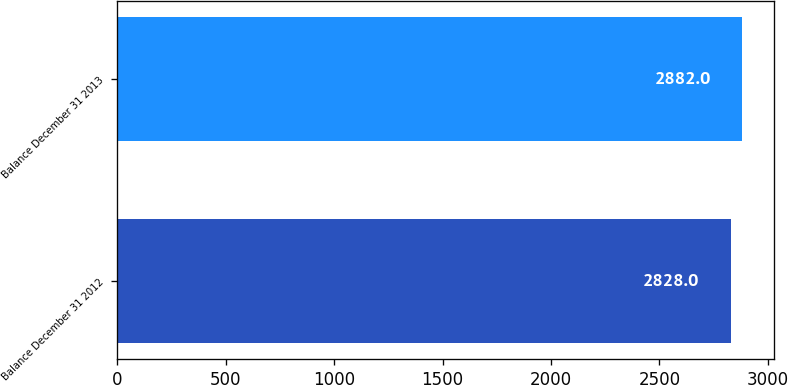Convert chart. <chart><loc_0><loc_0><loc_500><loc_500><bar_chart><fcel>Balance December 31 2012<fcel>Balance December 31 2013<nl><fcel>2828<fcel>2882<nl></chart> 